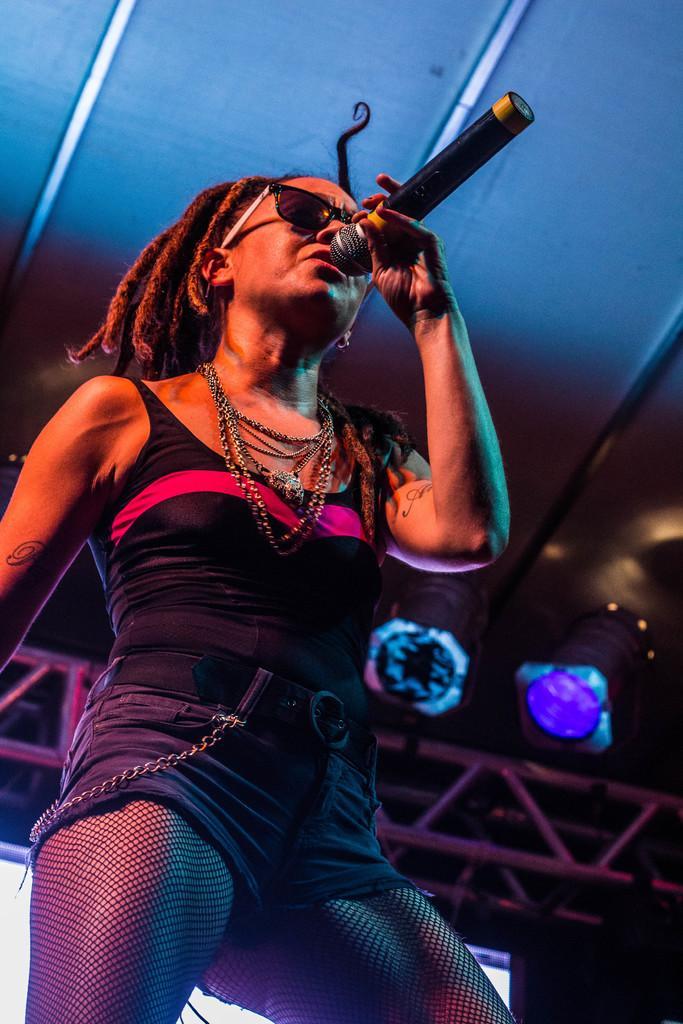Describe this image in one or two sentences. In this image in front there is a person holding the mike. Behind her there is a screen. On top of the image there are metal rods and lights. 